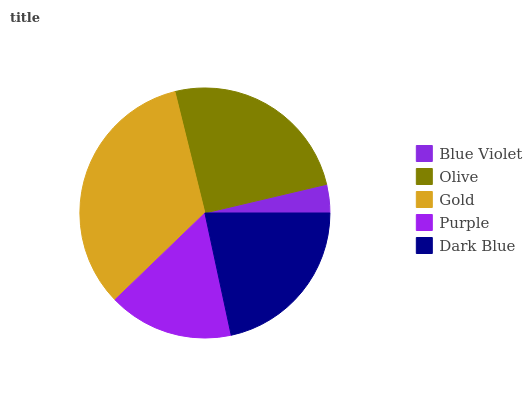Is Blue Violet the minimum?
Answer yes or no. Yes. Is Gold the maximum?
Answer yes or no. Yes. Is Olive the minimum?
Answer yes or no. No. Is Olive the maximum?
Answer yes or no. No. Is Olive greater than Blue Violet?
Answer yes or no. Yes. Is Blue Violet less than Olive?
Answer yes or no. Yes. Is Blue Violet greater than Olive?
Answer yes or no. No. Is Olive less than Blue Violet?
Answer yes or no. No. Is Dark Blue the high median?
Answer yes or no. Yes. Is Dark Blue the low median?
Answer yes or no. Yes. Is Purple the high median?
Answer yes or no. No. Is Blue Violet the low median?
Answer yes or no. No. 